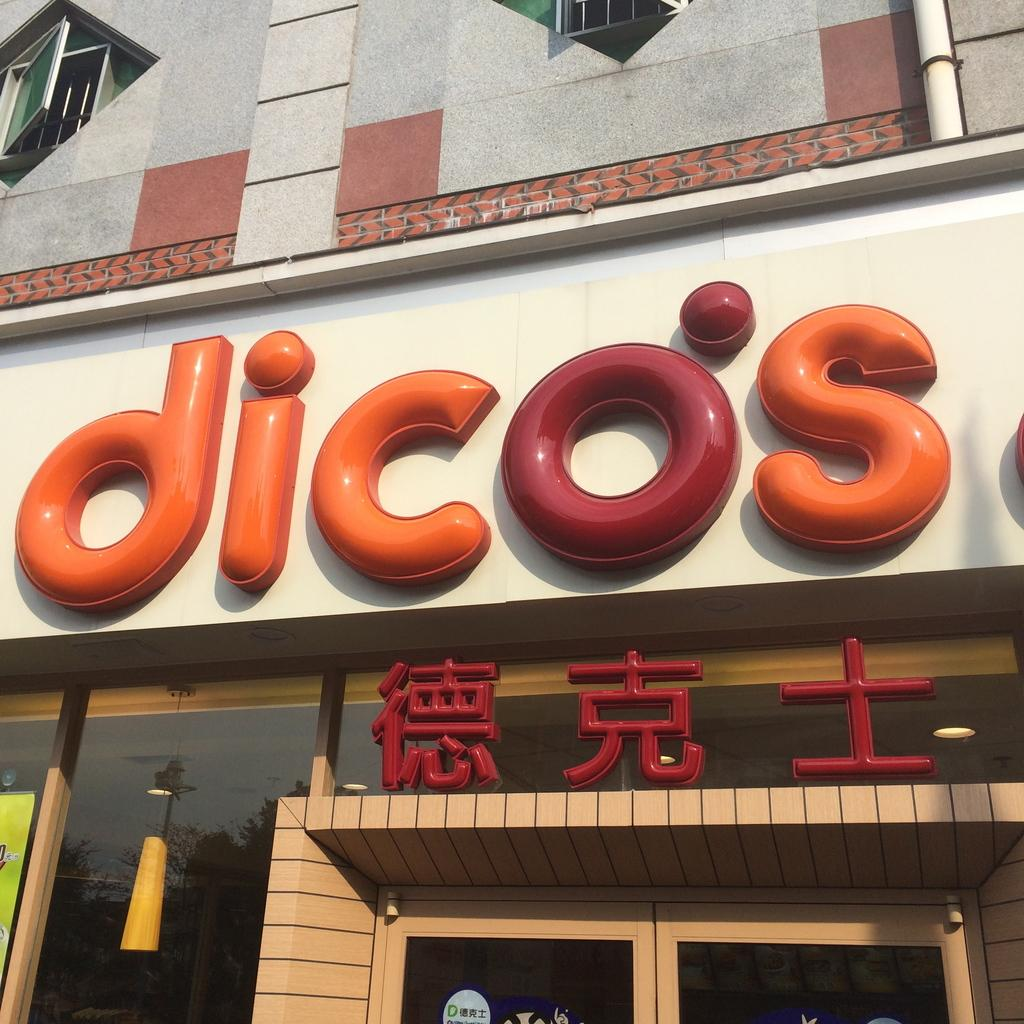What type of structure is visible in the image? There is a building in the image. What else can be seen in the image besides the building? There is a pipeline, windows, electric lights, and a store visible in the image. Can you see any steam coming from the ocean in the image? There is no ocean present in the image, so it is not possible to see any steam coming from it. 